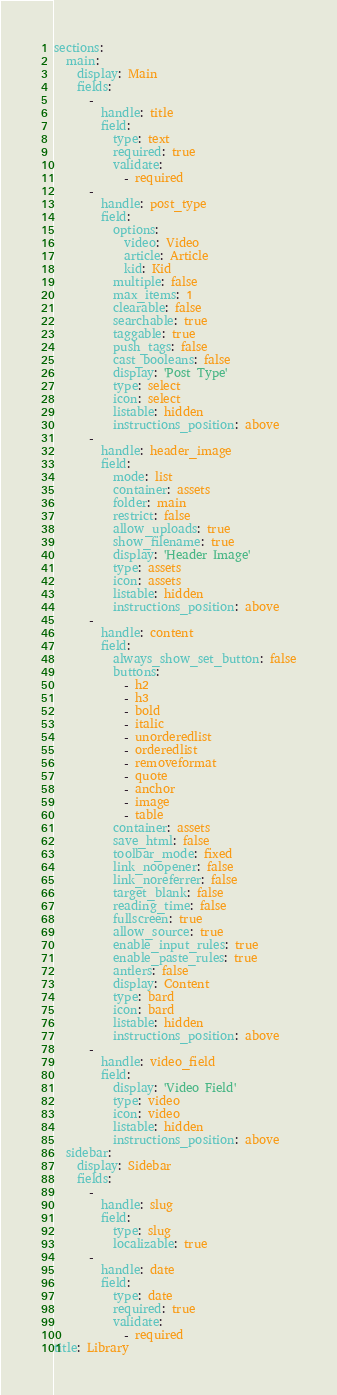<code> <loc_0><loc_0><loc_500><loc_500><_YAML_>sections:
  main:
    display: Main
    fields:
      -
        handle: title
        field:
          type: text
          required: true
          validate:
            - required
      -
        handle: post_type
        field:
          options:
            video: Video
            article: Article
            kid: Kid
          multiple: false
          max_items: 1
          clearable: false
          searchable: true
          taggable: true
          push_tags: false
          cast_booleans: false
          display: 'Post Type'
          type: select
          icon: select
          listable: hidden
          instructions_position: above
      -
        handle: header_image
        field:
          mode: list
          container: assets
          folder: main
          restrict: false
          allow_uploads: true
          show_filename: true
          display: 'Header Image'
          type: assets
          icon: assets
          listable: hidden
          instructions_position: above
      -
        handle: content
        field:
          always_show_set_button: false
          buttons:
            - h2
            - h3
            - bold
            - italic
            - unorderedlist
            - orderedlist
            - removeformat
            - quote
            - anchor
            - image
            - table
          container: assets
          save_html: false
          toolbar_mode: fixed
          link_noopener: false
          link_noreferrer: false
          target_blank: false
          reading_time: false
          fullscreen: true
          allow_source: true
          enable_input_rules: true
          enable_paste_rules: true
          antlers: false
          display: Content
          type: bard
          icon: bard
          listable: hidden
          instructions_position: above
      -
        handle: video_field
        field:
          display: 'Video Field'
          type: video
          icon: video
          listable: hidden
          instructions_position: above
  sidebar:
    display: Sidebar
    fields:
      -
        handle: slug
        field:
          type: slug
          localizable: true
      -
        handle: date
        field:
          type: date
          required: true
          validate:
            - required
title: Library
</code> 